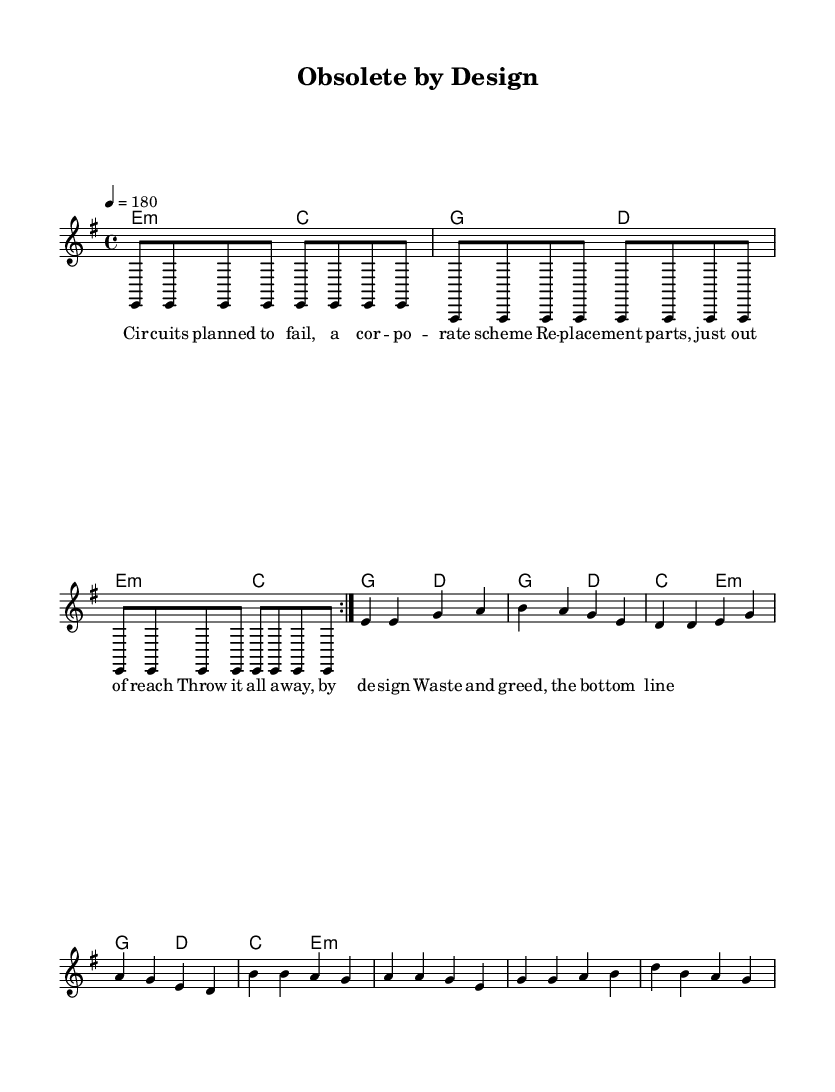What is the key signature of this music? The key signature includes one sharp, indicating that the music is in E minor. The key signature is placed at the beginning of the staff.
Answer: E minor What is the time signature of this music? The time signature is found at the beginning and is indicated as 4/4, meaning there are four beats per measure, and a quarter note receives one beat.
Answer: 4/4 What is the tempo marking for this piece? The tempo marking is indicated at the start of the score as 4 = 180, meaning there are 180 quarter note beats per minute.
Answer: 180 How many measures are there in the verse? To find the number of measures in the verse, we can count the measures of the melodyVerse section, which consists of four measures.
Answer: 4 What is the structure of the lyrics? The lyrics are divided into verses and chorus sections, with the verse discussing the theme of planned obsolescence and the chorus calling out waste and greed.
Answer: Verse and chorus What are the primary chords used in the verse? The chords listed for the verse are E minor and C major for the first half, followed by G major and D major for the second half.
Answer: E minor, C major, G major, D major What theme do the lyrics of the song emphasize? The lyrics critique corporate strategies that promote disposal and maintenance challenges, emphasizing waste and greed as part of their design.
Answer: Waste and greed 